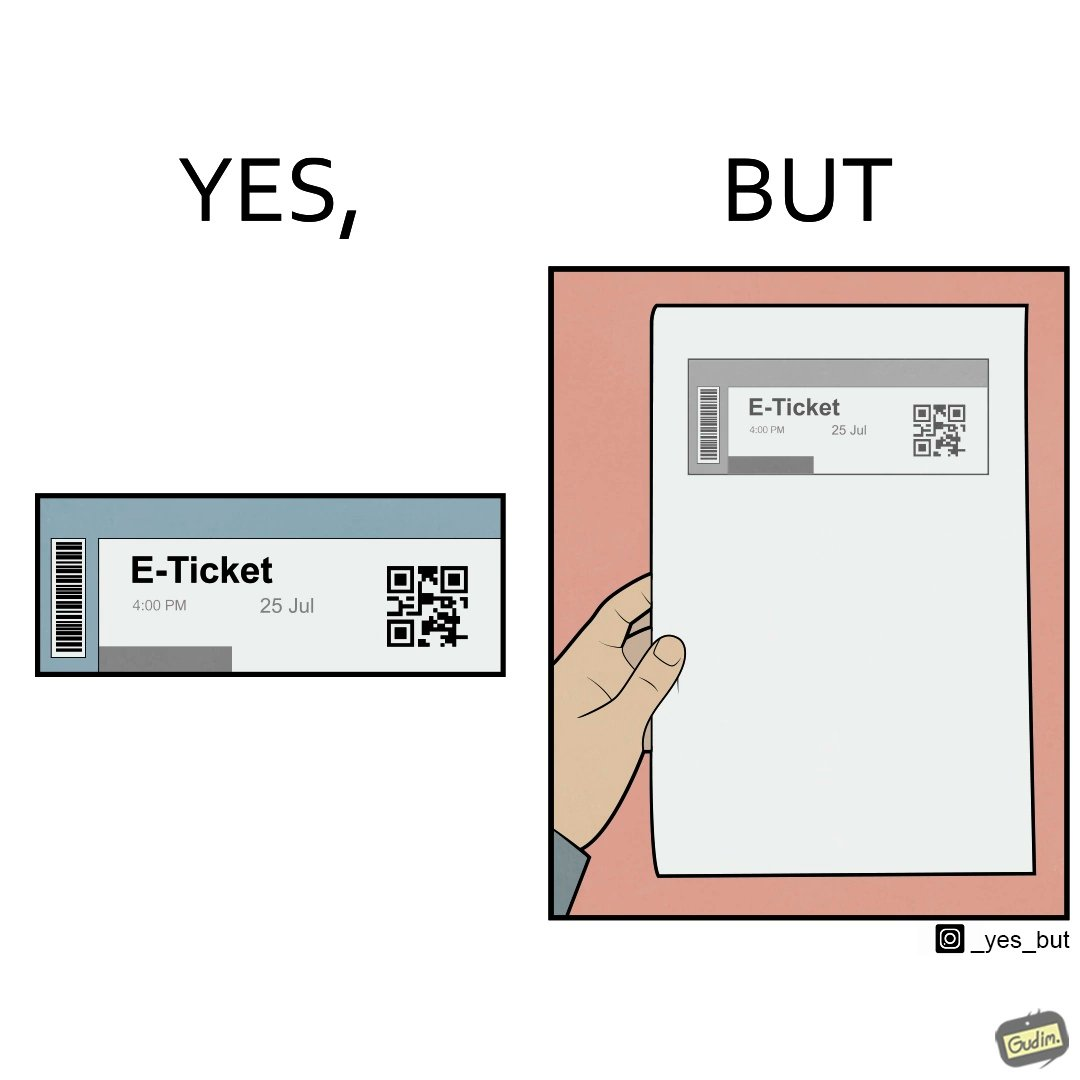Describe what you see in this image. The images are ironic since even though e-tickets are provided to save resources like paper, people choose to print out e-tickets on large sheets of paper which leads to more wastage 